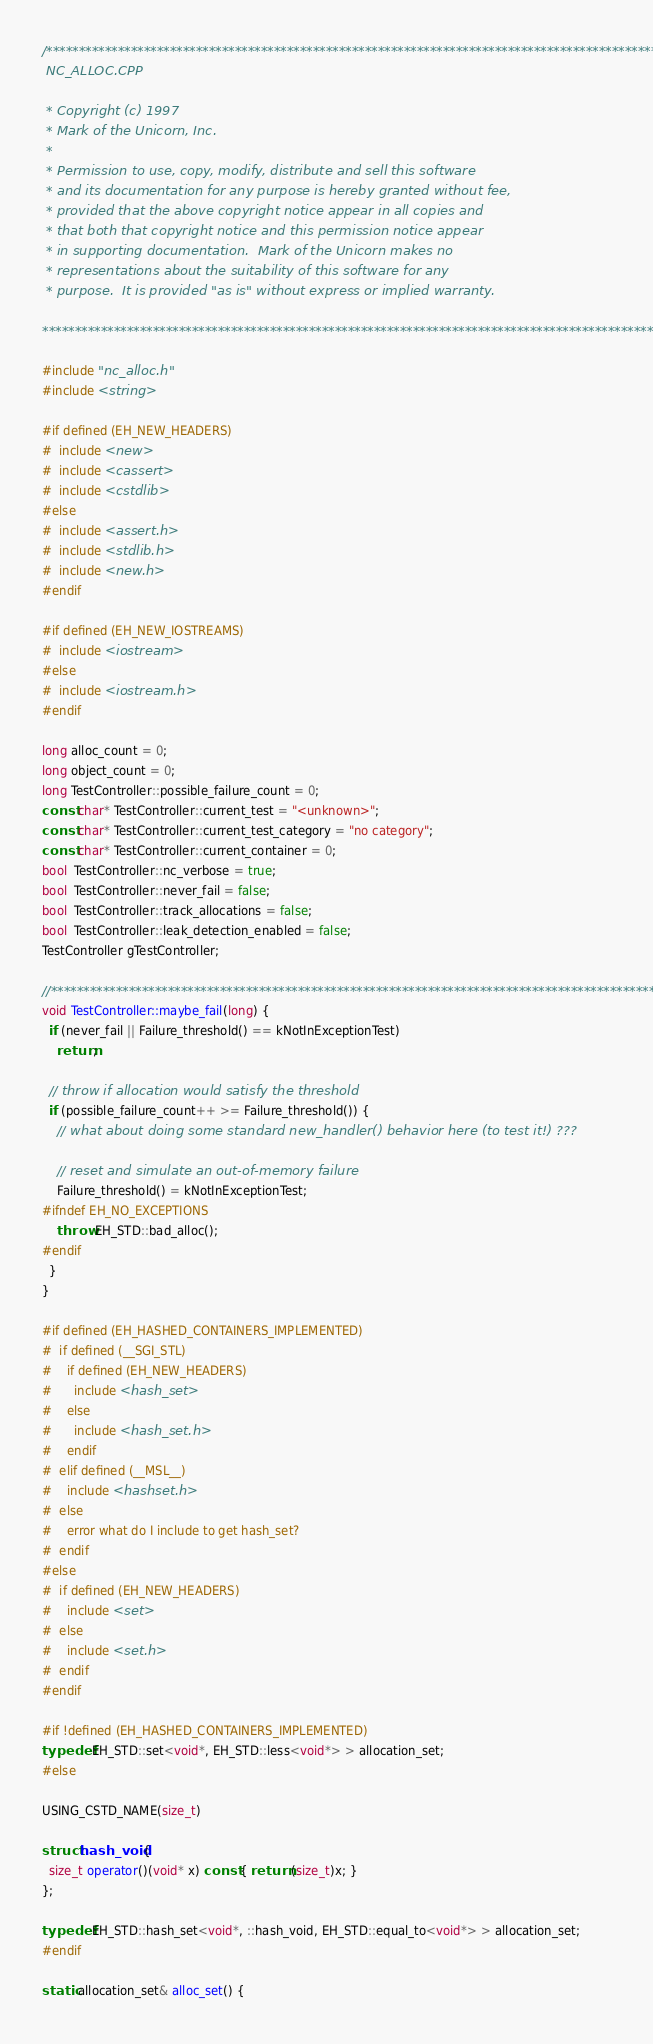<code> <loc_0><loc_0><loc_500><loc_500><_C++_>/************************************************************************************************
 NC_ALLOC.CPP

 * Copyright (c) 1997
 * Mark of the Unicorn, Inc.
 *
 * Permission to use, copy, modify, distribute and sell this software
 * and its documentation for any purpose is hereby granted without fee,
 * provided that the above copyright notice appear in all copies and
 * that both that copyright notice and this permission notice appear
 * in supporting documentation.  Mark of the Unicorn makes no
 * representations about the suitability of this software for any
 * purpose.  It is provided "as is" without express or implied warranty.

************************************************************************************************/

#include "nc_alloc.h"
#include <string>

#if defined (EH_NEW_HEADERS)
#  include <new>
#  include <cassert>
#  include <cstdlib>
#else
#  include <assert.h>
#  include <stdlib.h>
#  include <new.h>
#endif

#if defined (EH_NEW_IOSTREAMS)
#  include <iostream>
#else
#  include <iostream.h>
#endif

long alloc_count = 0;
long object_count = 0;
long TestController::possible_failure_count = 0;
const char* TestController::current_test = "<unknown>";
const char* TestController::current_test_category = "no category";
const char* TestController::current_container = 0;
bool  TestController::nc_verbose = true;
bool  TestController::never_fail = false;
bool  TestController::track_allocations = false;
bool  TestController::leak_detection_enabled = false;
TestController gTestController;

//************************************************************************************************
void TestController::maybe_fail(long) {
  if (never_fail || Failure_threshold() == kNotInExceptionTest)
    return;

  // throw if allocation would satisfy the threshold
  if (possible_failure_count++ >= Failure_threshold()) {
    // what about doing some standard new_handler() behavior here (to test it!) ???

    // reset and simulate an out-of-memory failure
    Failure_threshold() = kNotInExceptionTest;
#ifndef EH_NO_EXCEPTIONS
    throw EH_STD::bad_alloc();
#endif
  }
}

#if defined (EH_HASHED_CONTAINERS_IMPLEMENTED)
#  if defined (__SGI_STL)
#    if defined (EH_NEW_HEADERS)
#      include <hash_set>
#    else
#      include <hash_set.h>
#    endif
#  elif defined (__MSL__)
#    include <hashset.h>
#  else
#    error what do I include to get hash_set?
#  endif
#else
#  if defined (EH_NEW_HEADERS)
#    include <set>
#  else
#    include <set.h>
#  endif
#endif

#if !defined (EH_HASHED_CONTAINERS_IMPLEMENTED)
typedef EH_STD::set<void*, EH_STD::less<void*> > allocation_set;
#else

USING_CSTD_NAME(size_t)

struct hash_void {
  size_t operator()(void* x) const { return (size_t)x; }
};

typedef EH_STD::hash_set<void*, ::hash_void, EH_STD::equal_to<void*> > allocation_set;
#endif

static allocation_set& alloc_set() {</code> 